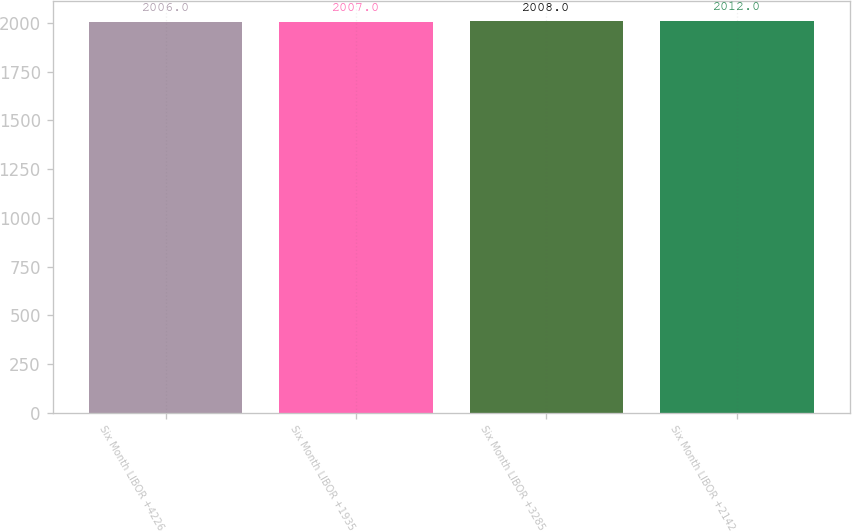Convert chart. <chart><loc_0><loc_0><loc_500><loc_500><bar_chart><fcel>Six Month LIBOR +4226<fcel>Six Month LIBOR +1935<fcel>Six Month LIBOR +3285<fcel>Six Month LIBOR +2142<nl><fcel>2006<fcel>2007<fcel>2008<fcel>2012<nl></chart> 